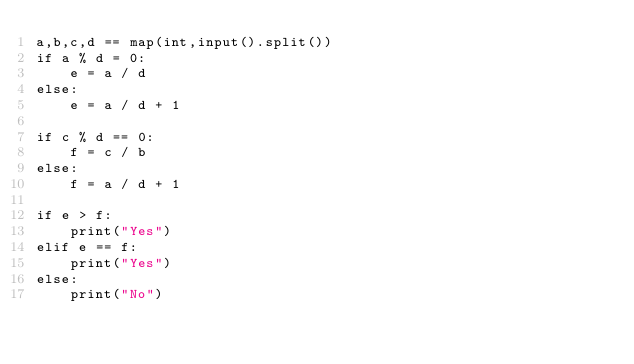Convert code to text. <code><loc_0><loc_0><loc_500><loc_500><_Python_>a,b,c,d == map(int,input().split())
if a % d = 0:
    e = a / d
else:
    e = a / d + 1

if c % d == 0:
    f = c / b
else:
    f = a / d + 1
    
if e > f:
    print("Yes")
elif e == f:
    print("Yes")
else:
    print("No")</code> 